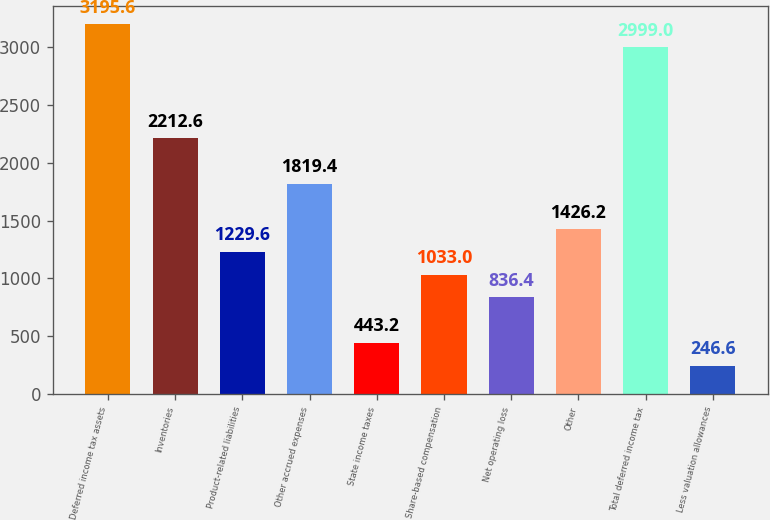Convert chart. <chart><loc_0><loc_0><loc_500><loc_500><bar_chart><fcel>Deferred income tax assets<fcel>Inventories<fcel>Product-related liabilities<fcel>Other accrued expenses<fcel>State income taxes<fcel>Share-based compensation<fcel>Net operating loss<fcel>Other<fcel>Total deferred income tax<fcel>Less valuation allowances<nl><fcel>3195.6<fcel>2212.6<fcel>1229.6<fcel>1819.4<fcel>443.2<fcel>1033<fcel>836.4<fcel>1426.2<fcel>2999<fcel>246.6<nl></chart> 